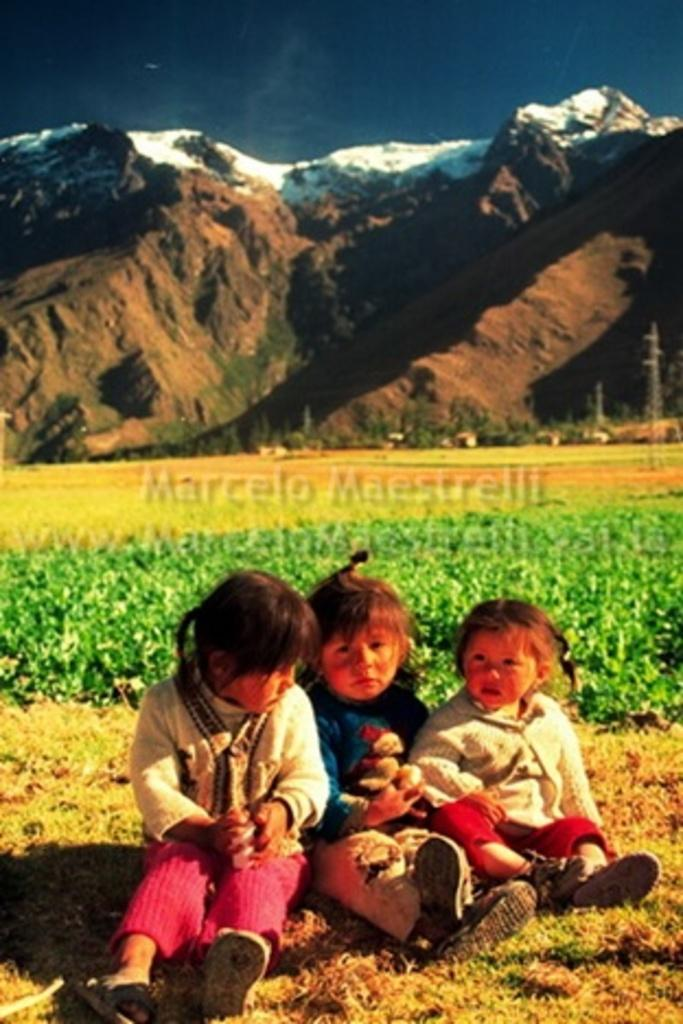What are the children in the image doing? The children are sitting on the ground in the image. What type of vegetation is visible in the background of the image? There is grass in the background of the image. What natural landmarks can be seen in the background of the image? There are mountains visible in the background of the image. What else is visible in the background of the image? The sky is visible in the background of the image. What type of wool is being spun by the rabbit in the image? There is no rabbit or wool present in the image; it features children sitting on the ground with grass, mountains, and sky in the background. 